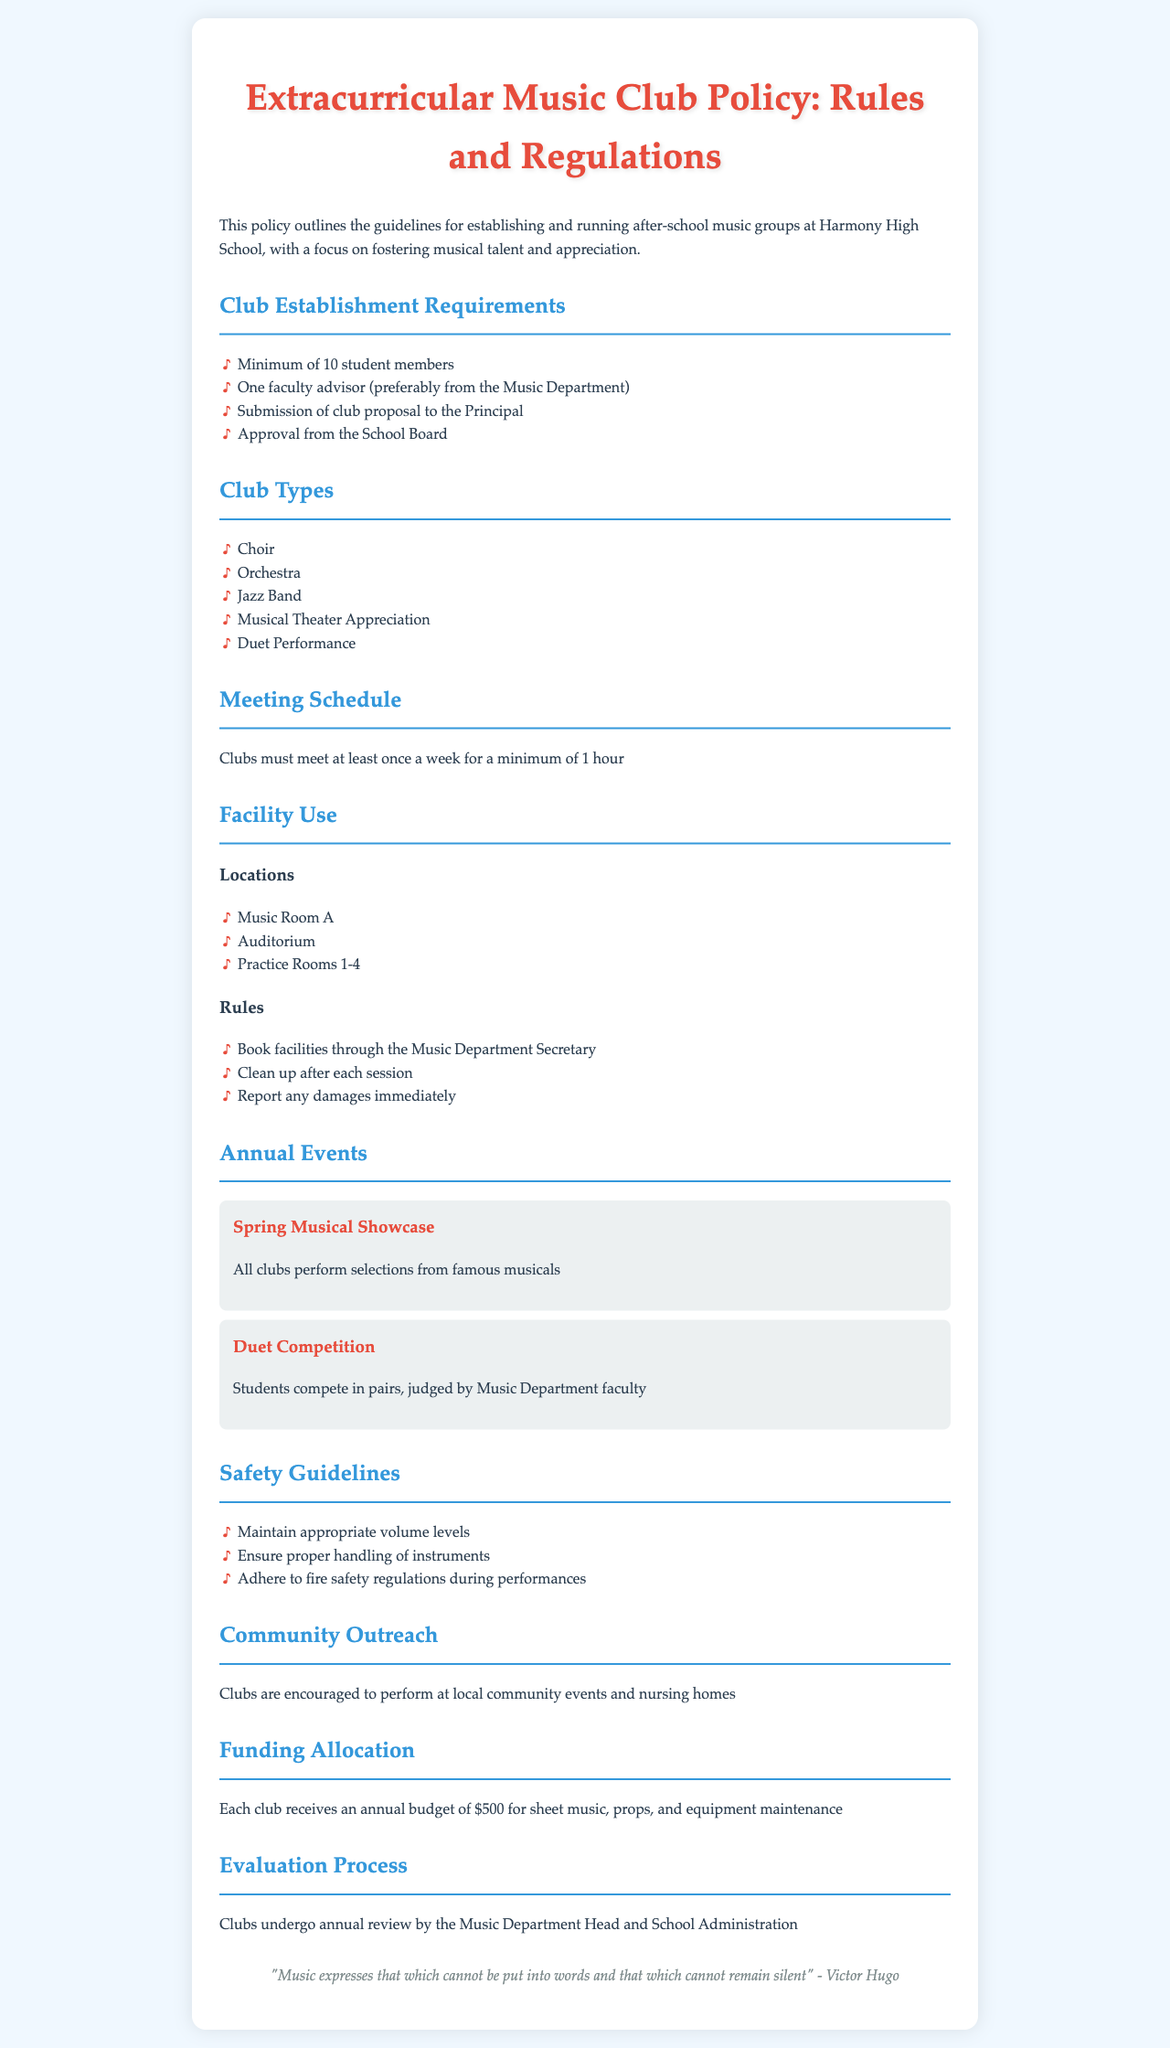What is the minimum number of student members required to establish a music club? The document states that a minimum of 10 student members is required to establish a music club.
Answer: 10 student members Who is required to be the faculty advisor for the club? The policy specifies that the faculty advisor should preferably be from the Music Department.
Answer: Music Department How often must clubs meet? The document indicates that clubs must meet at least once a week.
Answer: Once a week What is the annual budget allocated to each club? According to the document, each club receives an annual budget for various expenses.
Answer: $500 What type of event allows students to compete in pairs? The document mentions a specific event where students compete in pairs, judged by faculty.
Answer: Duet Competition Which locations are designated for club activities? The policy lists specific locations where clubs can hold their meetings.
Answer: Music Room A, Auditorium, Practice Rooms 1-4 What is the purpose of community outreach activities mentioned in the document? The document encourages clubs to engage in community outreach through performance activities.
Answer: Perform at local community events and nursing homes What is evaluated during the annual review process for clubs? The annual review process assesses the performance of clubs as outlined in the policy.
Answer: Clubs What is one of the safety guidelines mentioned for club activities? The document outlines safety guidelines that should be followed during club activities.
Answer: Maintain appropriate volume levels 